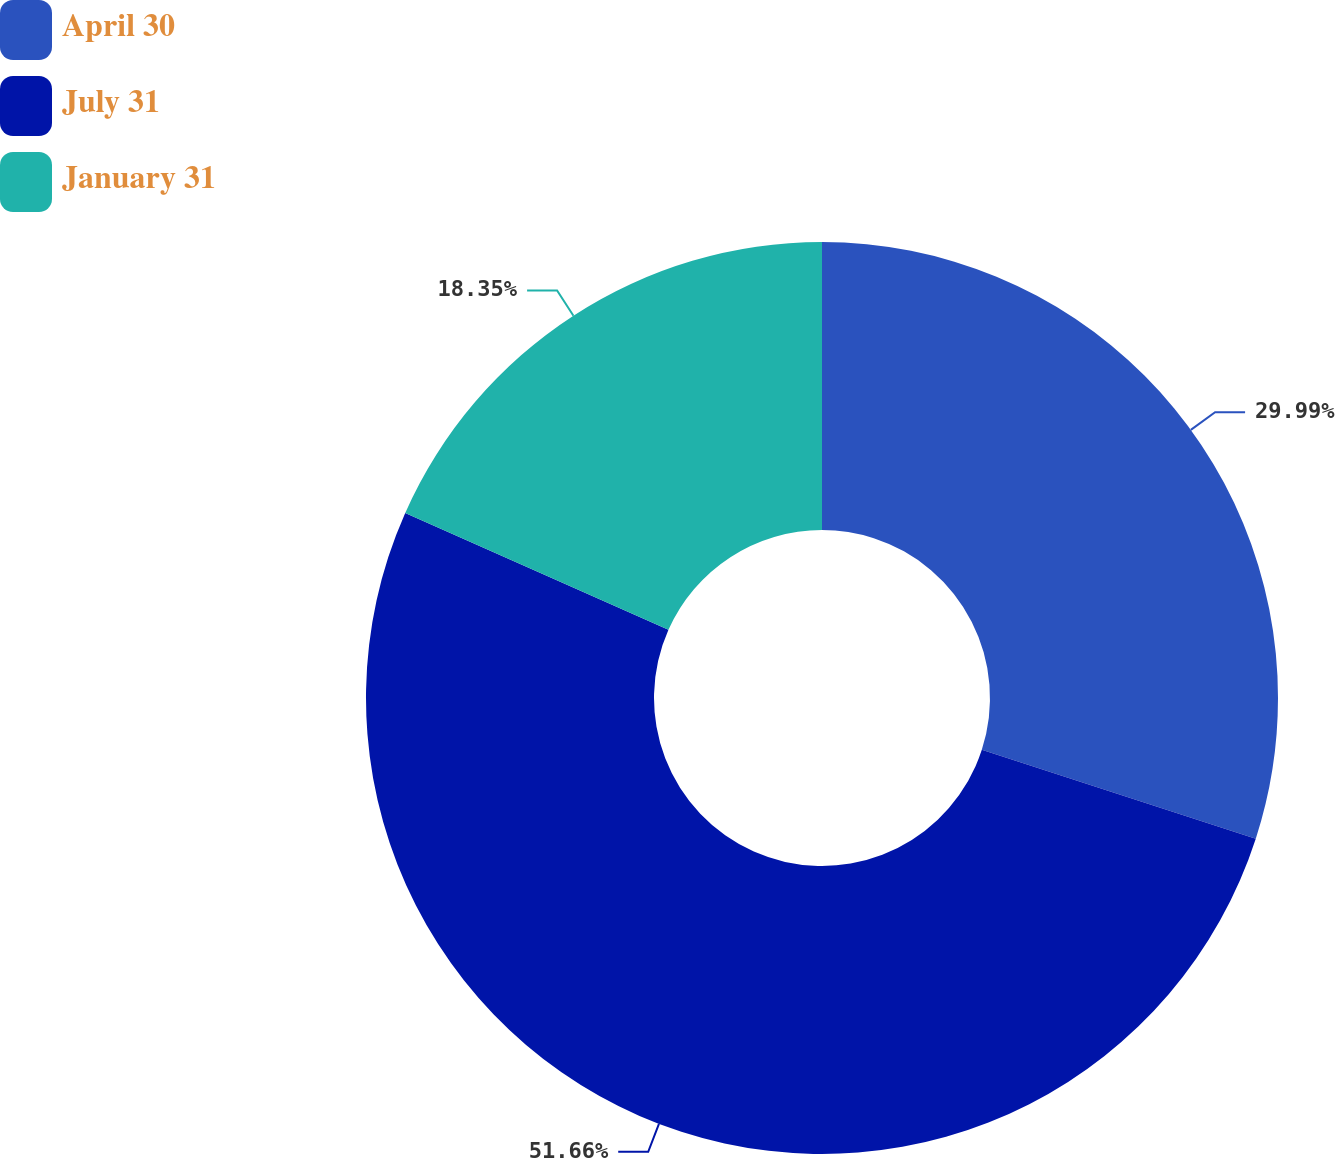Convert chart to OTSL. <chart><loc_0><loc_0><loc_500><loc_500><pie_chart><fcel>April 30<fcel>July 31<fcel>January 31<nl><fcel>29.99%<fcel>51.66%<fcel>18.35%<nl></chart> 